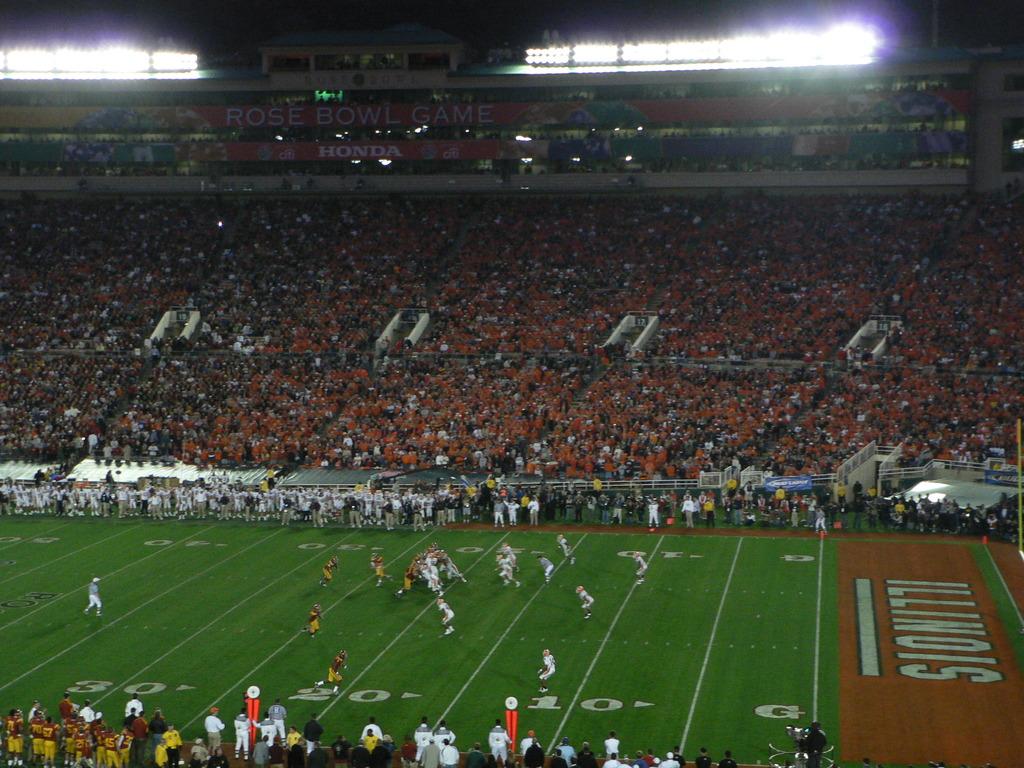What state's touchdown line can be seen?
Provide a succinct answer. Illinois. 